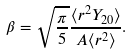<formula> <loc_0><loc_0><loc_500><loc_500>\beta = \sqrt { \frac { \pi } { 5 } } \frac { \langle r ^ { 2 } Y _ { 2 0 } \rangle } { A \langle r ^ { 2 } \rangle } .</formula> 